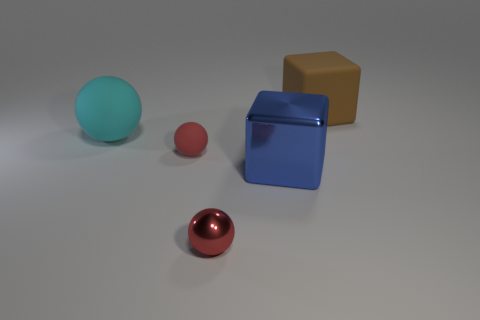Add 1 tiny purple matte blocks. How many objects exist? 6 Subtract all spheres. How many objects are left? 2 Add 5 cyan rubber spheres. How many cyan rubber spheres are left? 6 Add 5 matte balls. How many matte balls exist? 7 Subtract 0 purple cylinders. How many objects are left? 5 Subtract all rubber cubes. Subtract all large blocks. How many objects are left? 2 